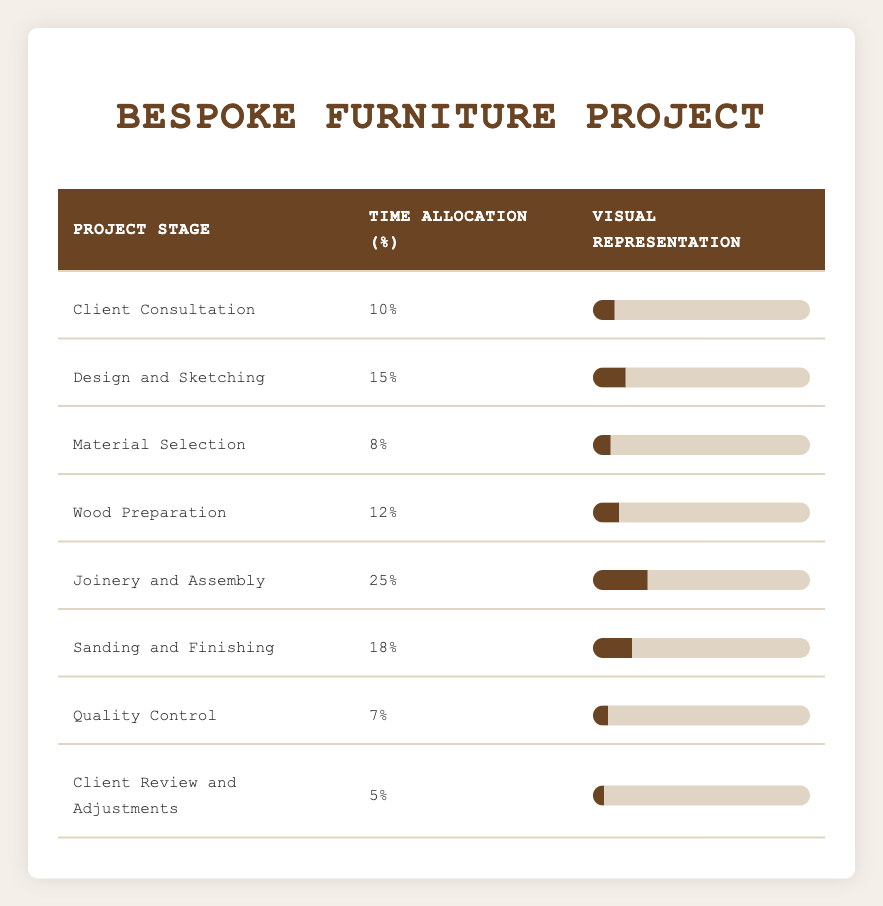What is the time allocation for 'Joinery and Assembly'? The table shows that 'Joinery and Assembly' has a time allocation of 25%.
Answer: 25% Which project stage has the least time allocation? By examining the table, 'Quality Control' is the stage with the least time allocation at 7%.
Answer: 7% What percentage of the project is dedicated to 'Client Consultation' and 'Material Selection' combined? To find the combined percentage, add the time allocations for 'Client Consultation' (10%) and 'Material Selection' (8%) together: 10 + 8 = 18%.
Answer: 18% Is the time allocation for 'Sanding and Finishing' greater than that of 'Wood Preparation'? The table shows that 'Sanding and Finishing' has an allocation of 18% while 'Wood Preparation' has 12%. Since 18% is greater than 12%, the answer is yes.
Answer: Yes What is the total time allocation for all stages of the project? Adding all the percentages from each stage: 10 + 15 + 8 + 12 + 25 + 18 + 7 + 5 = 100%. Therefore, the total time allocation is 100%.
Answer: 100% What percentage of the project is not allocated to 'Client Review and Adjustments'? Calculate the total allocation for all stages except 'Client Review and Adjustments' (5%): 100% - 5% = 95%.
Answer: 95% How does the time allocation for 'Design and Sketching' compare to 'Material Selection'? 'Design and Sketching' has an allocation of 15%, while 'Material Selection' has 8%. Since 15% is greater than 8%, 'Design and Sketching' has a higher allocation.
Answer: Design and Sketching is greater If everything else remains constant but 'Joinery and Assembly' time is reduced by 5%, what would be the new percentage? If we reduce 'Joinery and Assembly' from 25% to 20%, it would then represent 20% of the total allocation.
Answer: 20% What stage will require the most time after 'Joinery and Assembly'? The next highest time allocation after 'Joinery and Assembly' at 25% is 'Sanding and Finishing' at 18%.
Answer: Sanding and Finishing 